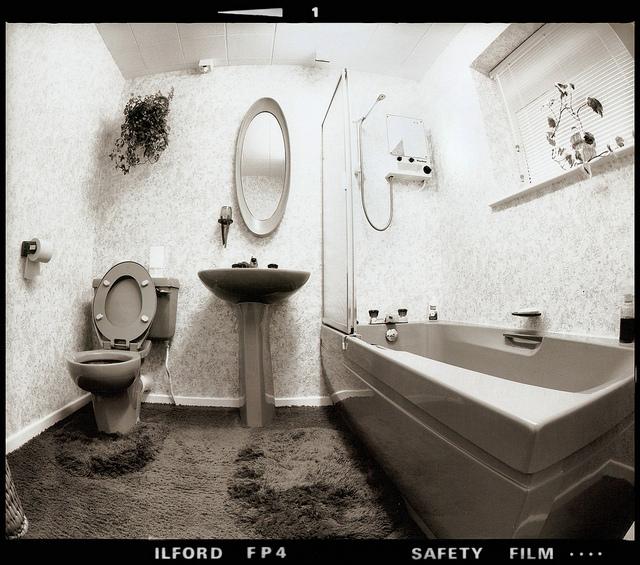Is there anyone in the bathtub?
Write a very short answer. No. Are there any plants in this image?
Answer briefly. Yes. What kind of carpet is shown?
Write a very short answer. Shag. 